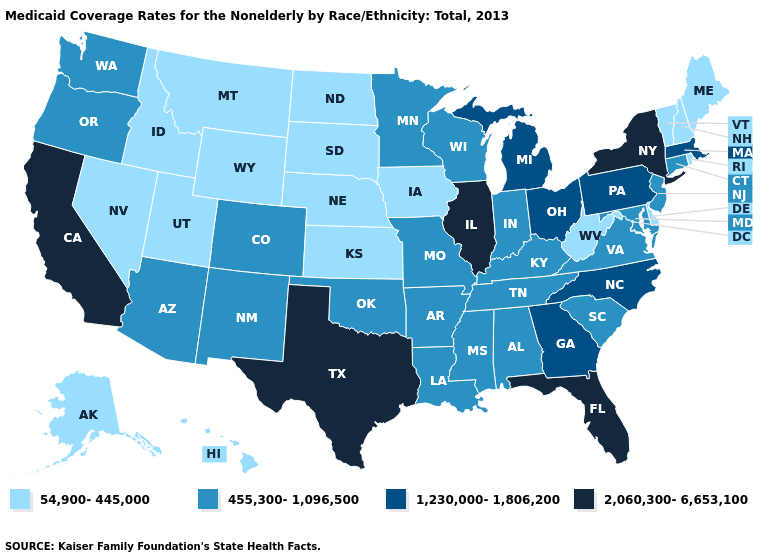Name the states that have a value in the range 2,060,300-6,653,100?
Concise answer only. California, Florida, Illinois, New York, Texas. Among the states that border Indiana , which have the lowest value?
Concise answer only. Kentucky. What is the value of Idaho?
Be succinct. 54,900-445,000. What is the lowest value in the USA?
Concise answer only. 54,900-445,000. Does Rhode Island have the lowest value in the USA?
Keep it brief. Yes. Name the states that have a value in the range 1,230,000-1,806,200?
Write a very short answer. Georgia, Massachusetts, Michigan, North Carolina, Ohio, Pennsylvania. Does Alaska have the lowest value in the West?
Short answer required. Yes. What is the highest value in states that border Michigan?
Keep it brief. 1,230,000-1,806,200. What is the value of Florida?
Concise answer only. 2,060,300-6,653,100. Which states hav the highest value in the Northeast?
Be succinct. New York. What is the value of Tennessee?
Give a very brief answer. 455,300-1,096,500. What is the highest value in the USA?
Short answer required. 2,060,300-6,653,100. Which states have the lowest value in the West?
Keep it brief. Alaska, Hawaii, Idaho, Montana, Nevada, Utah, Wyoming. Does Nevada have the lowest value in the USA?
Short answer required. Yes. Name the states that have a value in the range 54,900-445,000?
Be succinct. Alaska, Delaware, Hawaii, Idaho, Iowa, Kansas, Maine, Montana, Nebraska, Nevada, New Hampshire, North Dakota, Rhode Island, South Dakota, Utah, Vermont, West Virginia, Wyoming. 